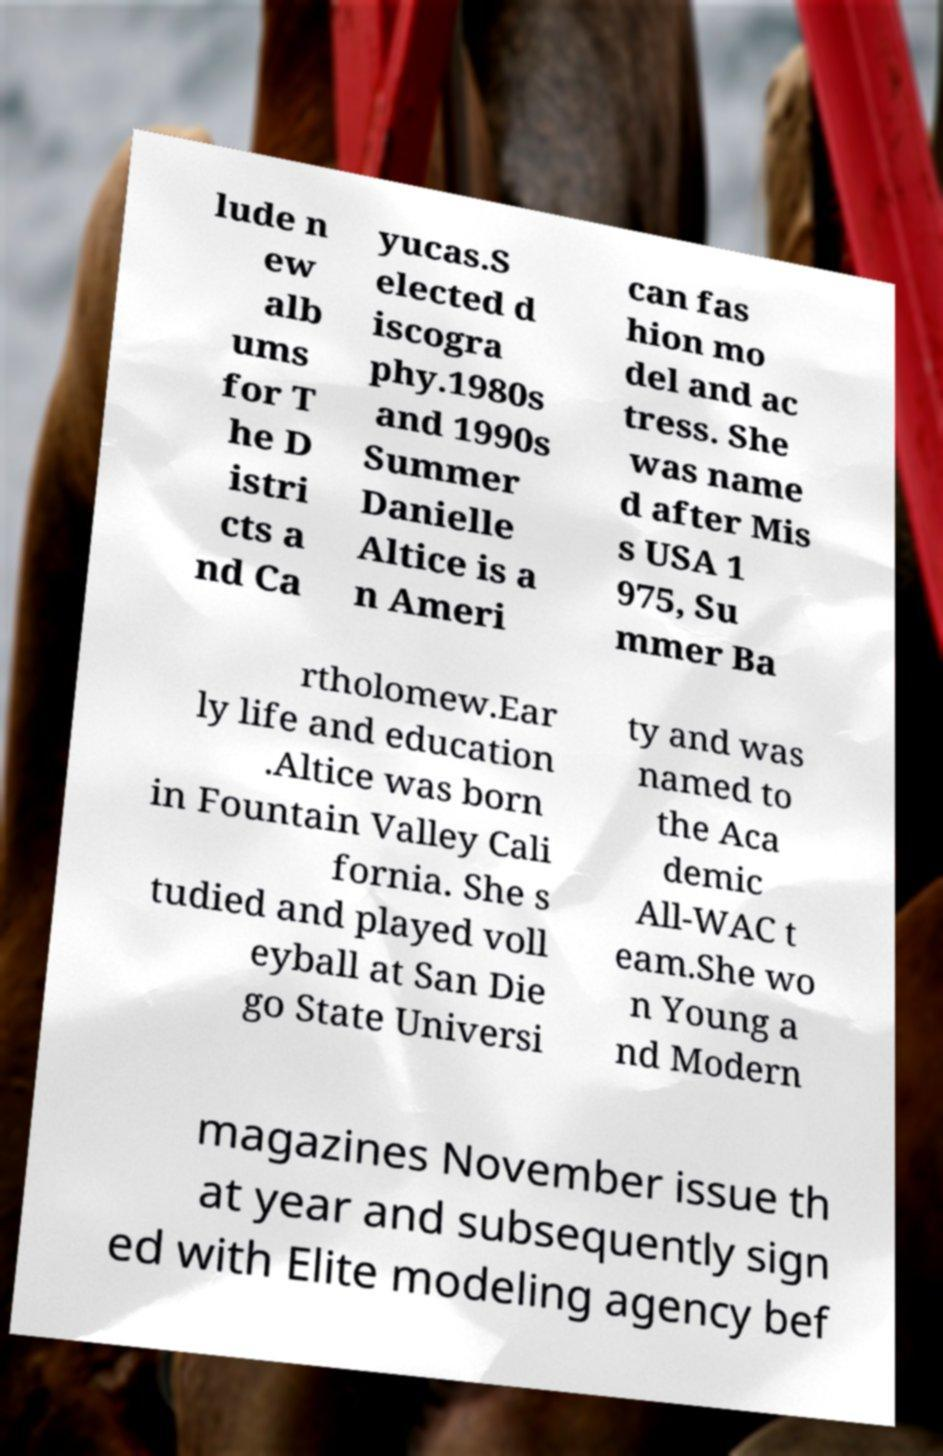Could you assist in decoding the text presented in this image and type it out clearly? lude n ew alb ums for T he D istri cts a nd Ca yucas.S elected d iscogra phy.1980s and 1990s Summer Danielle Altice is a n Ameri can fas hion mo del and ac tress. She was name d after Mis s USA 1 975, Su mmer Ba rtholomew.Ear ly life and education .Altice was born in Fountain Valley Cali fornia. She s tudied and played voll eyball at San Die go State Universi ty and was named to the Aca demic All-WAC t eam.She wo n Young a nd Modern magazines November issue th at year and subsequently sign ed with Elite modeling agency bef 